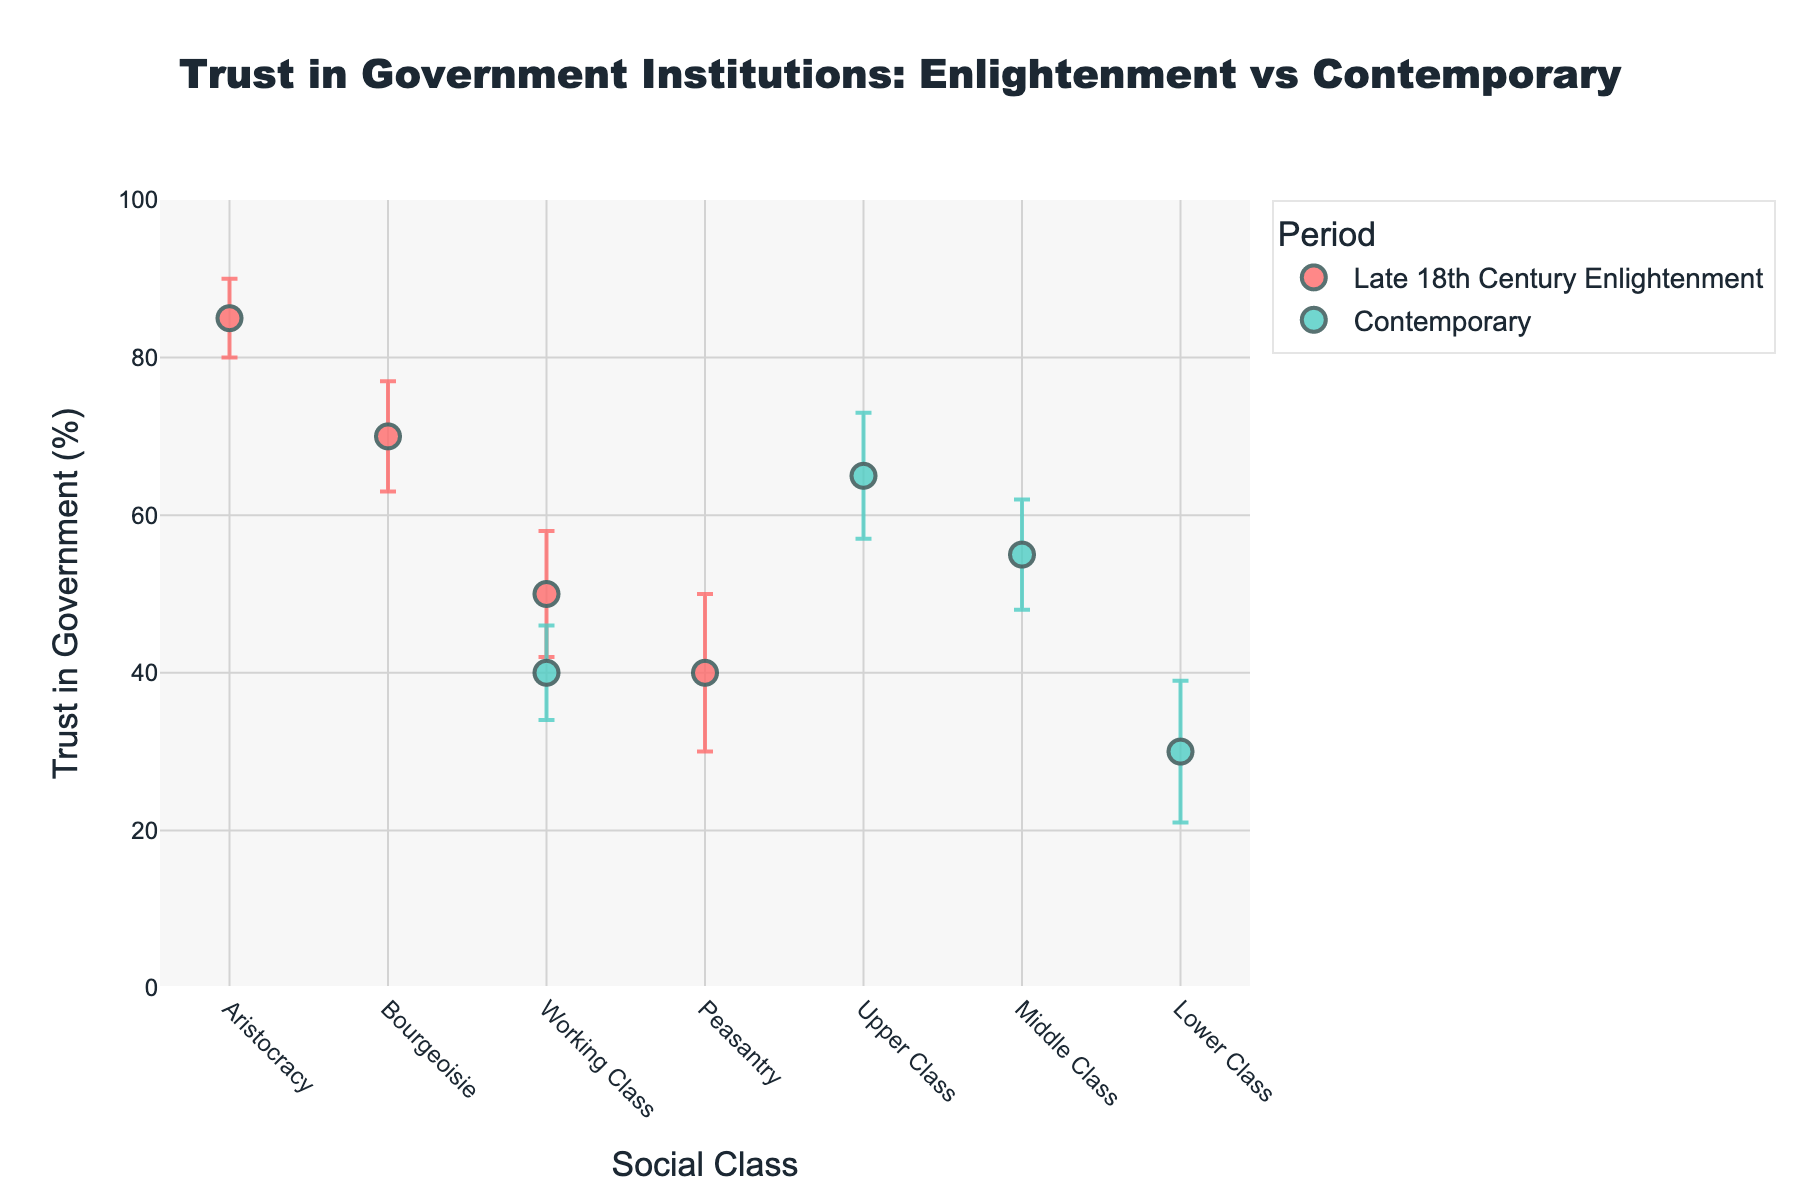What is the title of the figure? The title of the figure is prominently displayed at the top. It reads "Trust in Government Institutions: Enlightenment vs Contemporary".
Answer: Trust in Government Institutions: Enlightenment vs Contemporary What is the trust percentage of the Working Class in the Late 18th Century Enlightenment? By looking at the dot plot, find the data point labeled "Late 18th Century Enlightenment" for the Working Class. The corresponding trust percentage is shown on the y-axis.
Answer: 50% Which social class has the highest trust in government during the Late 18th Century Enlightenment period? Identify the tallest marker in the Late 18th Century Enlightenment series. The label associated with this marker is "Aristocracy".
Answer: Aristocracy How much higher is the trust in government for the Aristocracy compared to the Peasantry in the Late 18th Century Enlightenment period? Locate the markers for Aristocracy and Peasantry in the Late 18th Century Enlightenment period. Aristocracy has a trust value of 85, and Peasantry has 40. Subtract 40 from 85 to find the difference.
Answer: 45 Which social class has the smallest error bar in the Contemporary period? Review the length of the error bars for each social class in the Contemporary period. The class with the shortest error bar is the Working Class with an error of 6.
Answer: Working Class How does the trust in government of the Upper Class in the Contemporary period compare to the Aristocracy in the Late 18th Century Enlightenment? Compare the trust values for the Upper Class in the Contemporary period (65) and the Aristocracy in the Late 18th Century Enlightenment (85). The Upper Class has lower trust.
Answer: Lower What is the average trust in government for the social classes in the Late 18th Century Enlightenment period? List the trust percentages for all classes in the Late 18th Century Enlightenment period (85, 70, 50, 40). Sum these values and divide by the number of classes, i.e., (85+70+50+40)/4.
Answer: 61.25% Which Contemporary social class shows a similar level of trust as the Bourgeoisie in the Late 18th Century Enlightenment? The Bourgeoisie in the Late 18th Century Enlightenment has a trust percentage of 70. Look for a nearby value in the Contemporary period classes. None of the Contemporary classes match exactly, but the Upper Class is the closest with a value of 65.
Answer: Upper Class What can be inferred from the trust trend across social classes between the Late 18th Century Enlightenment and Contemporary periods? Observe the markers across the two periods. Trust in government decreases consistently from higher to lower classes in both periods, indicating a widened trust gap and overall reduced trust in the Contemporary period.
Answer: Trust decreased across all classes over time 